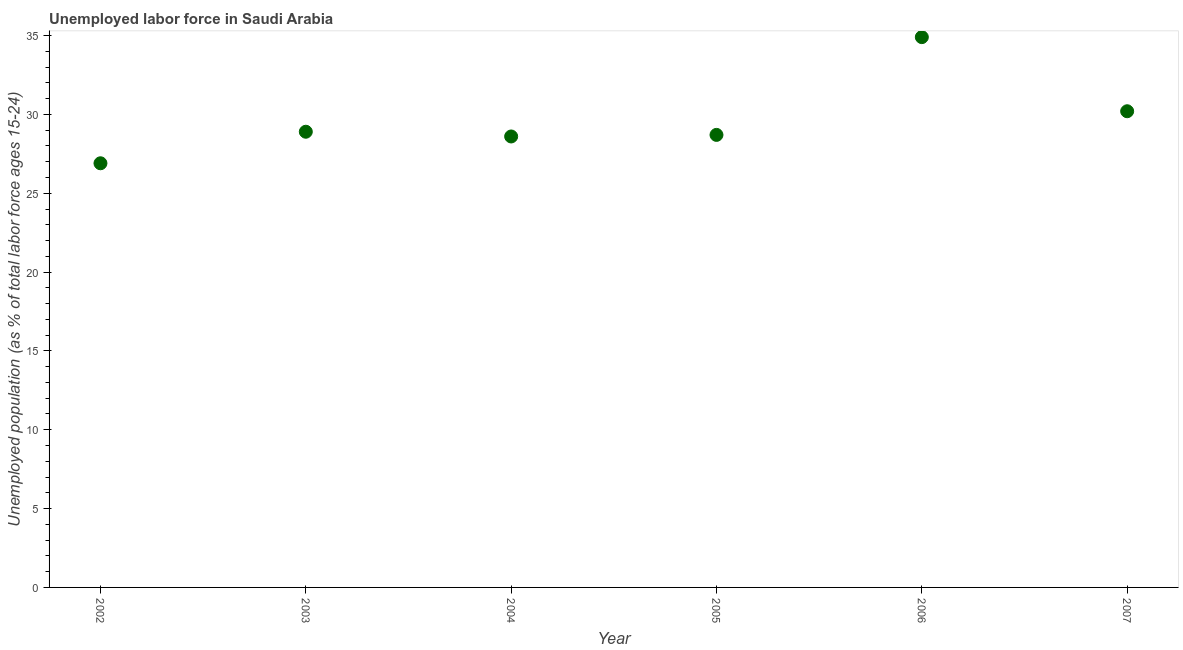What is the total unemployed youth population in 2005?
Your answer should be very brief. 28.7. Across all years, what is the maximum total unemployed youth population?
Provide a succinct answer. 34.9. Across all years, what is the minimum total unemployed youth population?
Provide a short and direct response. 26.9. In which year was the total unemployed youth population minimum?
Your answer should be compact. 2002. What is the sum of the total unemployed youth population?
Offer a terse response. 178.2. What is the average total unemployed youth population per year?
Offer a terse response. 29.7. What is the median total unemployed youth population?
Offer a very short reply. 28.8. In how many years, is the total unemployed youth population greater than 22 %?
Offer a very short reply. 6. What is the ratio of the total unemployed youth population in 2003 to that in 2004?
Keep it short and to the point. 1.01. Is the total unemployed youth population in 2003 less than that in 2004?
Keep it short and to the point. No. What is the difference between the highest and the second highest total unemployed youth population?
Offer a very short reply. 4.7. What is the difference between the highest and the lowest total unemployed youth population?
Offer a terse response. 8. In how many years, is the total unemployed youth population greater than the average total unemployed youth population taken over all years?
Ensure brevity in your answer.  2. Does the total unemployed youth population monotonically increase over the years?
Your response must be concise. No. What is the difference between two consecutive major ticks on the Y-axis?
Your answer should be very brief. 5. Are the values on the major ticks of Y-axis written in scientific E-notation?
Your response must be concise. No. What is the title of the graph?
Provide a short and direct response. Unemployed labor force in Saudi Arabia. What is the label or title of the Y-axis?
Give a very brief answer. Unemployed population (as % of total labor force ages 15-24). What is the Unemployed population (as % of total labor force ages 15-24) in 2002?
Give a very brief answer. 26.9. What is the Unemployed population (as % of total labor force ages 15-24) in 2003?
Give a very brief answer. 28.9. What is the Unemployed population (as % of total labor force ages 15-24) in 2004?
Offer a very short reply. 28.6. What is the Unemployed population (as % of total labor force ages 15-24) in 2005?
Make the answer very short. 28.7. What is the Unemployed population (as % of total labor force ages 15-24) in 2006?
Your response must be concise. 34.9. What is the Unemployed population (as % of total labor force ages 15-24) in 2007?
Your answer should be compact. 30.2. What is the difference between the Unemployed population (as % of total labor force ages 15-24) in 2002 and 2004?
Keep it short and to the point. -1.7. What is the difference between the Unemployed population (as % of total labor force ages 15-24) in 2002 and 2005?
Offer a very short reply. -1.8. What is the difference between the Unemployed population (as % of total labor force ages 15-24) in 2002 and 2006?
Provide a short and direct response. -8. What is the difference between the Unemployed population (as % of total labor force ages 15-24) in 2003 and 2004?
Your answer should be compact. 0.3. What is the difference between the Unemployed population (as % of total labor force ages 15-24) in 2003 and 2005?
Give a very brief answer. 0.2. What is the difference between the Unemployed population (as % of total labor force ages 15-24) in 2003 and 2007?
Keep it short and to the point. -1.3. What is the difference between the Unemployed population (as % of total labor force ages 15-24) in 2005 and 2007?
Your answer should be compact. -1.5. What is the ratio of the Unemployed population (as % of total labor force ages 15-24) in 2002 to that in 2004?
Provide a short and direct response. 0.94. What is the ratio of the Unemployed population (as % of total labor force ages 15-24) in 2002 to that in 2005?
Offer a terse response. 0.94. What is the ratio of the Unemployed population (as % of total labor force ages 15-24) in 2002 to that in 2006?
Your answer should be very brief. 0.77. What is the ratio of the Unemployed population (as % of total labor force ages 15-24) in 2002 to that in 2007?
Your answer should be very brief. 0.89. What is the ratio of the Unemployed population (as % of total labor force ages 15-24) in 2003 to that in 2004?
Give a very brief answer. 1.01. What is the ratio of the Unemployed population (as % of total labor force ages 15-24) in 2003 to that in 2006?
Provide a succinct answer. 0.83. What is the ratio of the Unemployed population (as % of total labor force ages 15-24) in 2004 to that in 2005?
Ensure brevity in your answer.  1. What is the ratio of the Unemployed population (as % of total labor force ages 15-24) in 2004 to that in 2006?
Your answer should be very brief. 0.82. What is the ratio of the Unemployed population (as % of total labor force ages 15-24) in 2004 to that in 2007?
Offer a terse response. 0.95. What is the ratio of the Unemployed population (as % of total labor force ages 15-24) in 2005 to that in 2006?
Give a very brief answer. 0.82. What is the ratio of the Unemployed population (as % of total labor force ages 15-24) in 2005 to that in 2007?
Provide a succinct answer. 0.95. What is the ratio of the Unemployed population (as % of total labor force ages 15-24) in 2006 to that in 2007?
Make the answer very short. 1.16. 